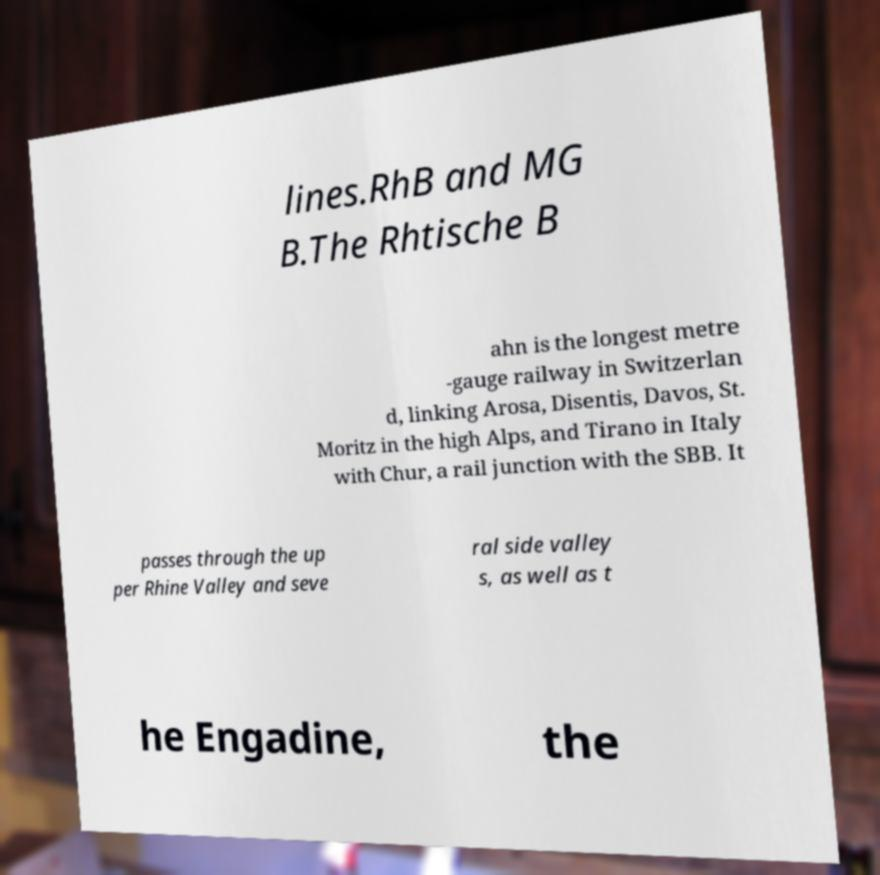What messages or text are displayed in this image? I need them in a readable, typed format. lines.RhB and MG B.The Rhtische B ahn is the longest metre -gauge railway in Switzerlan d, linking Arosa, Disentis, Davos, St. Moritz in the high Alps, and Tirano in Italy with Chur, a rail junction with the SBB. It passes through the up per Rhine Valley and seve ral side valley s, as well as t he Engadine, the 